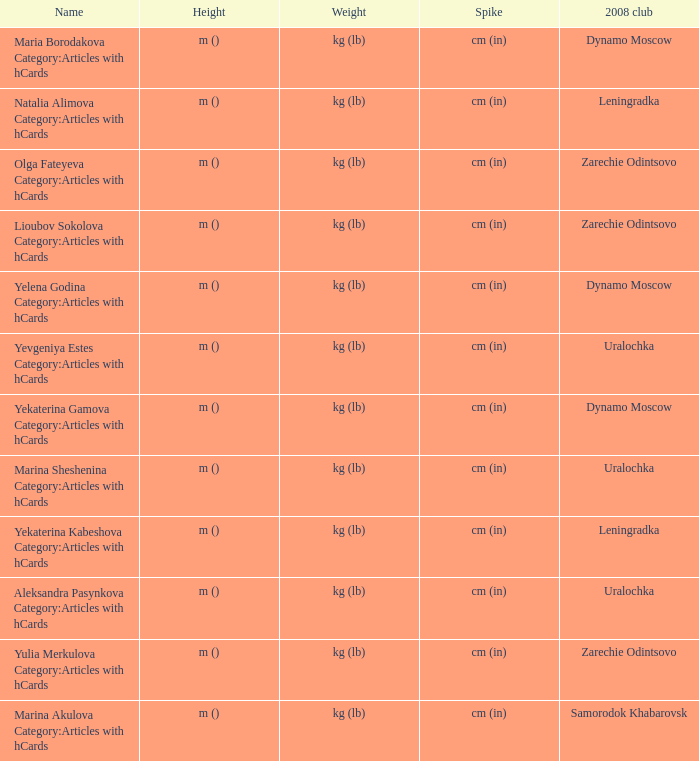What was the name of zarechie odintsovo club during 2008? Olga Fateyeva Category:Articles with hCards, Lioubov Sokolova Category:Articles with hCards, Yulia Merkulova Category:Articles with hCards. 